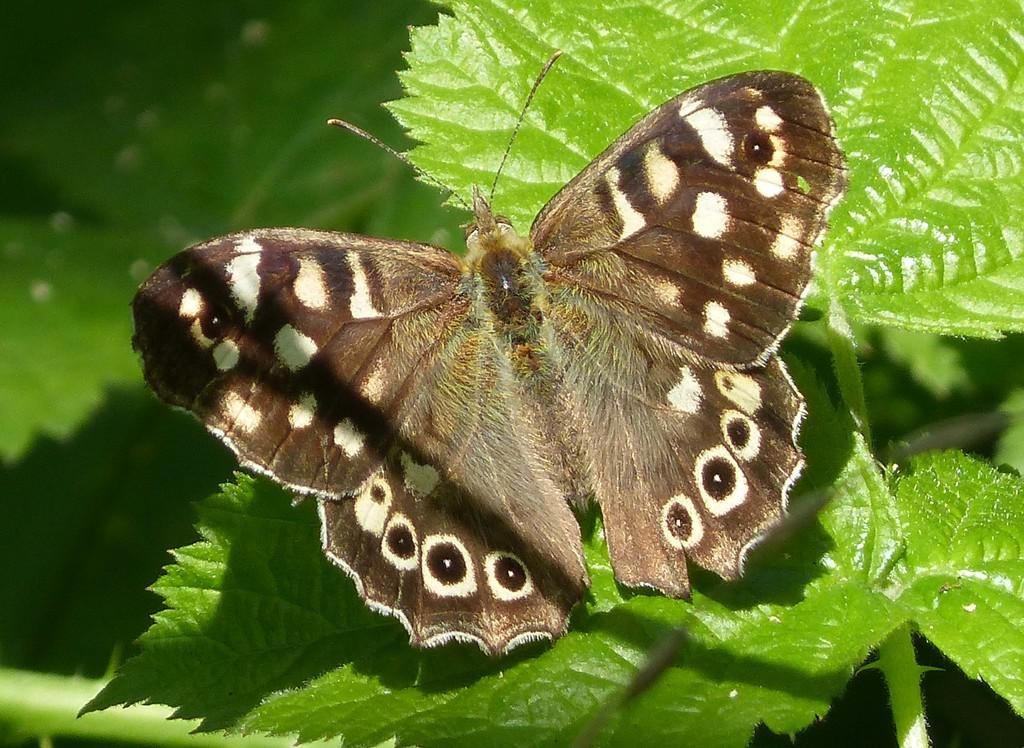What is the main subject of the image? There is a butterfly in the image. Where is the butterfly located? The butterfly is on a greenery leaf. What type of cough medicine is the butterfly holding in the image? There is no cough medicine present in the image, as it features a butterfly on a greenery leaf. 